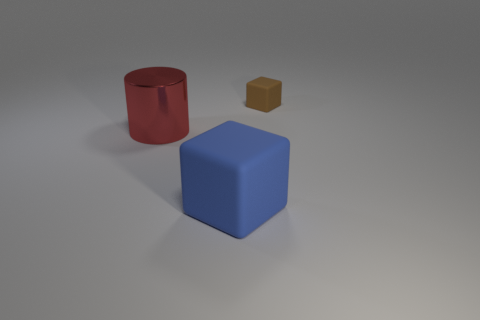Subtract all blue cubes. How many cubes are left? 1 Add 2 blue blocks. How many objects exist? 5 Subtract all big blue rubber blocks. Subtract all metal cylinders. How many objects are left? 1 Add 1 brown rubber cubes. How many brown rubber cubes are left? 2 Add 1 gray cubes. How many gray cubes exist? 1 Subtract 0 blue cylinders. How many objects are left? 3 Subtract all blocks. How many objects are left? 1 Subtract all green blocks. Subtract all cyan cylinders. How many blocks are left? 2 Subtract all cyan spheres. How many brown cubes are left? 1 